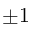<formula> <loc_0><loc_0><loc_500><loc_500>\pm 1</formula> 